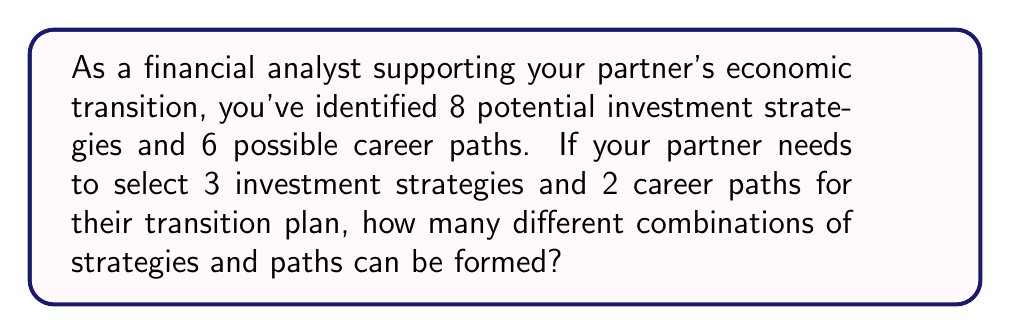What is the answer to this math problem? Let's break this down step-by-step:

1) For the investment strategies:
   - We need to choose 3 strategies out of 8 options
   - This is a combination problem, as the order doesn't matter
   - We use the combination formula: $${n \choose k} = \frac{n!}{k!(n-k)!}$$
   - In this case, $n = 8$ and $k = 3$
   - So, we calculate: $$\binom{8}{3} = \frac{8!}{3!(8-3)!} = \frac{8!}{3!5!} = 56$$

2) For the career paths:
   - We need to choose 2 paths out of 6 options
   - Again, this is a combination
   - Using the same formula with $n = 6$ and $k = 2$:
   - $$\binom{6}{2} = \frac{6!}{2!(6-2)!} = \frac{6!}{2!4!} = 15$$

3) To find the total number of possible combinations:
   - We use the multiplication principle
   - Total combinations = (Number of investment strategy combinations) × (Number of career path combinations)
   - Total combinations = $56 \times 15 = 840$

Therefore, there are 840 different possible combinations of strategies and paths.
Answer: 840 